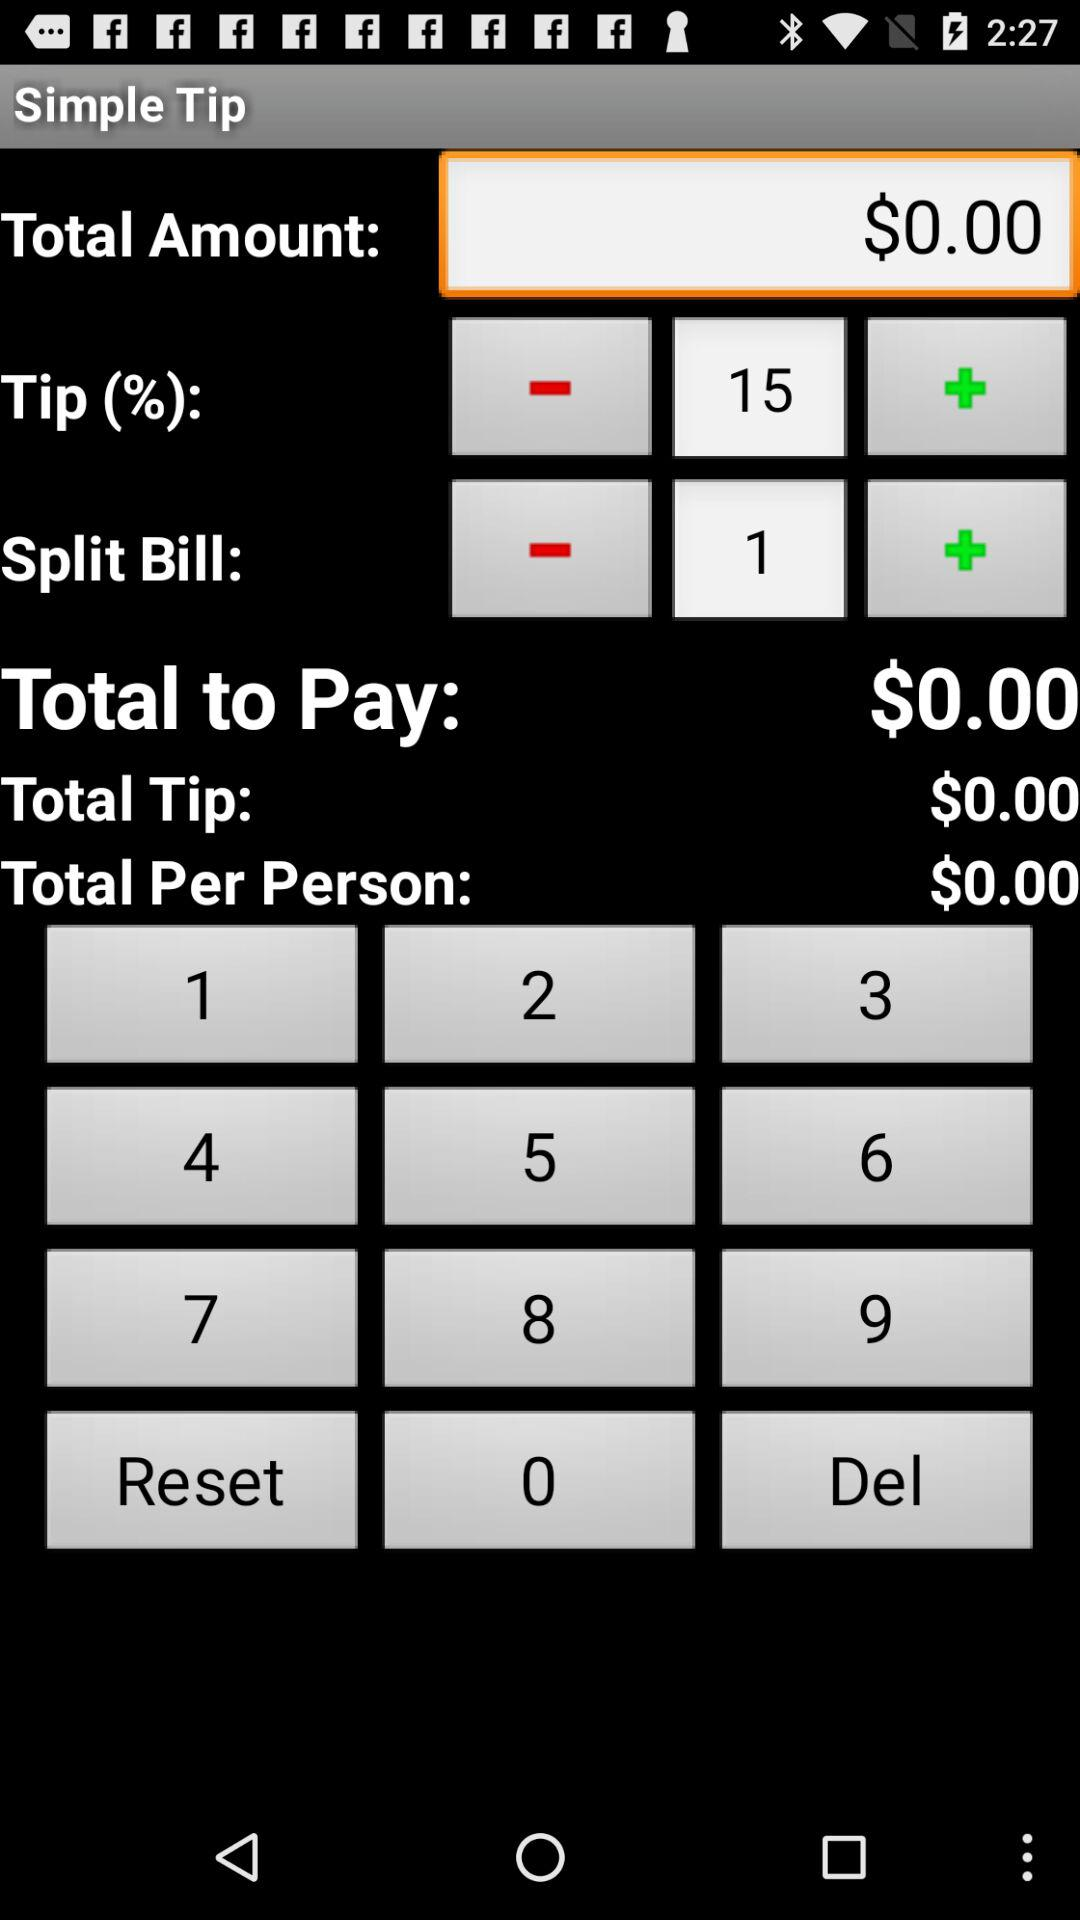What is the total amount of the bill?
Answer the question using a single word or phrase. $0.00 